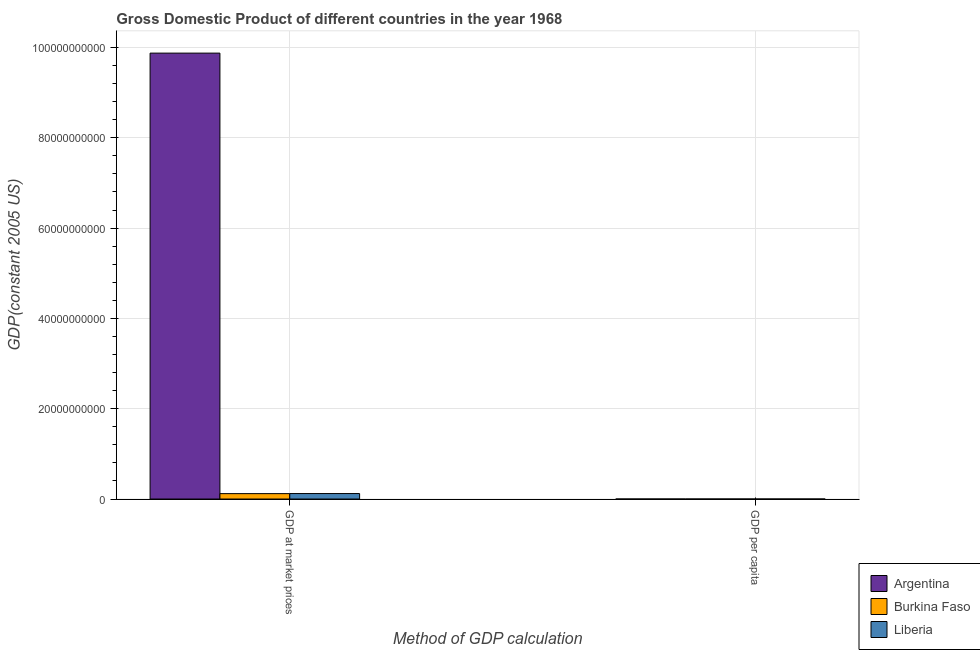Are the number of bars per tick equal to the number of legend labels?
Your answer should be very brief. Yes. Are the number of bars on each tick of the X-axis equal?
Ensure brevity in your answer.  Yes. How many bars are there on the 2nd tick from the left?
Offer a terse response. 3. What is the label of the 1st group of bars from the left?
Give a very brief answer. GDP at market prices. What is the gdp at market prices in Argentina?
Provide a succinct answer. 9.88e+1. Across all countries, what is the maximum gdp at market prices?
Provide a succinct answer. 9.88e+1. Across all countries, what is the minimum gdp at market prices?
Keep it short and to the point. 1.20e+09. In which country was the gdp per capita minimum?
Provide a short and direct response. Burkina Faso. What is the total gdp at market prices in the graph?
Give a very brief answer. 1.01e+11. What is the difference between the gdp at market prices in Liberia and that in Burkina Faso?
Give a very brief answer. 1.54e+07. What is the difference between the gdp at market prices in Argentina and the gdp per capita in Burkina Faso?
Give a very brief answer. 9.88e+1. What is the average gdp at market prices per country?
Ensure brevity in your answer.  3.37e+1. What is the difference between the gdp at market prices and gdp per capita in Liberia?
Your answer should be compact. 1.21e+09. What is the ratio of the gdp at market prices in Argentina to that in Liberia?
Make the answer very short. 81.49. In how many countries, is the gdp per capita greater than the average gdp per capita taken over all countries?
Your answer should be compact. 1. What does the 2nd bar from the left in GDP at market prices represents?
Offer a very short reply. Burkina Faso. What does the 3rd bar from the right in GDP at market prices represents?
Provide a succinct answer. Argentina. How many bars are there?
Ensure brevity in your answer.  6. Are all the bars in the graph horizontal?
Give a very brief answer. No. How many countries are there in the graph?
Offer a terse response. 3. What is the difference between two consecutive major ticks on the Y-axis?
Give a very brief answer. 2.00e+1. What is the title of the graph?
Your answer should be very brief. Gross Domestic Product of different countries in the year 1968. What is the label or title of the X-axis?
Your answer should be compact. Method of GDP calculation. What is the label or title of the Y-axis?
Provide a short and direct response. GDP(constant 2005 US). What is the GDP(constant 2005 US) in Argentina in GDP at market prices?
Give a very brief answer. 9.88e+1. What is the GDP(constant 2005 US) in Burkina Faso in GDP at market prices?
Keep it short and to the point. 1.20e+09. What is the GDP(constant 2005 US) of Liberia in GDP at market prices?
Offer a very short reply. 1.21e+09. What is the GDP(constant 2005 US) of Argentina in GDP per capita?
Provide a short and direct response. 4245.61. What is the GDP(constant 2005 US) in Burkina Faso in GDP per capita?
Offer a terse response. 220.19. What is the GDP(constant 2005 US) in Liberia in GDP per capita?
Ensure brevity in your answer.  898.75. Across all Method of GDP calculation, what is the maximum GDP(constant 2005 US) in Argentina?
Your answer should be very brief. 9.88e+1. Across all Method of GDP calculation, what is the maximum GDP(constant 2005 US) of Burkina Faso?
Offer a terse response. 1.20e+09. Across all Method of GDP calculation, what is the maximum GDP(constant 2005 US) of Liberia?
Offer a very short reply. 1.21e+09. Across all Method of GDP calculation, what is the minimum GDP(constant 2005 US) in Argentina?
Offer a very short reply. 4245.61. Across all Method of GDP calculation, what is the minimum GDP(constant 2005 US) in Burkina Faso?
Provide a short and direct response. 220.19. Across all Method of GDP calculation, what is the minimum GDP(constant 2005 US) of Liberia?
Offer a very short reply. 898.75. What is the total GDP(constant 2005 US) in Argentina in the graph?
Your answer should be compact. 9.88e+1. What is the total GDP(constant 2005 US) of Burkina Faso in the graph?
Offer a terse response. 1.20e+09. What is the total GDP(constant 2005 US) in Liberia in the graph?
Ensure brevity in your answer.  1.21e+09. What is the difference between the GDP(constant 2005 US) of Argentina in GDP at market prices and that in GDP per capita?
Make the answer very short. 9.88e+1. What is the difference between the GDP(constant 2005 US) of Burkina Faso in GDP at market prices and that in GDP per capita?
Provide a succinct answer. 1.20e+09. What is the difference between the GDP(constant 2005 US) of Liberia in GDP at market prices and that in GDP per capita?
Your response must be concise. 1.21e+09. What is the difference between the GDP(constant 2005 US) of Argentina in GDP at market prices and the GDP(constant 2005 US) of Burkina Faso in GDP per capita?
Offer a very short reply. 9.88e+1. What is the difference between the GDP(constant 2005 US) of Argentina in GDP at market prices and the GDP(constant 2005 US) of Liberia in GDP per capita?
Make the answer very short. 9.88e+1. What is the difference between the GDP(constant 2005 US) of Burkina Faso in GDP at market prices and the GDP(constant 2005 US) of Liberia in GDP per capita?
Provide a short and direct response. 1.20e+09. What is the average GDP(constant 2005 US) of Argentina per Method of GDP calculation?
Provide a short and direct response. 4.94e+1. What is the average GDP(constant 2005 US) in Burkina Faso per Method of GDP calculation?
Ensure brevity in your answer.  5.98e+08. What is the average GDP(constant 2005 US) of Liberia per Method of GDP calculation?
Your response must be concise. 6.06e+08. What is the difference between the GDP(constant 2005 US) of Argentina and GDP(constant 2005 US) of Burkina Faso in GDP at market prices?
Keep it short and to the point. 9.76e+1. What is the difference between the GDP(constant 2005 US) in Argentina and GDP(constant 2005 US) in Liberia in GDP at market prices?
Keep it short and to the point. 9.75e+1. What is the difference between the GDP(constant 2005 US) in Burkina Faso and GDP(constant 2005 US) in Liberia in GDP at market prices?
Your answer should be very brief. -1.54e+07. What is the difference between the GDP(constant 2005 US) of Argentina and GDP(constant 2005 US) of Burkina Faso in GDP per capita?
Offer a very short reply. 4025.43. What is the difference between the GDP(constant 2005 US) in Argentina and GDP(constant 2005 US) in Liberia in GDP per capita?
Your answer should be very brief. 3346.86. What is the difference between the GDP(constant 2005 US) in Burkina Faso and GDP(constant 2005 US) in Liberia in GDP per capita?
Make the answer very short. -678.56. What is the ratio of the GDP(constant 2005 US) of Argentina in GDP at market prices to that in GDP per capita?
Make the answer very short. 2.33e+07. What is the ratio of the GDP(constant 2005 US) of Burkina Faso in GDP at market prices to that in GDP per capita?
Ensure brevity in your answer.  5.43e+06. What is the ratio of the GDP(constant 2005 US) of Liberia in GDP at market prices to that in GDP per capita?
Make the answer very short. 1.35e+06. What is the difference between the highest and the second highest GDP(constant 2005 US) in Argentina?
Ensure brevity in your answer.  9.88e+1. What is the difference between the highest and the second highest GDP(constant 2005 US) in Burkina Faso?
Make the answer very short. 1.20e+09. What is the difference between the highest and the second highest GDP(constant 2005 US) of Liberia?
Your answer should be compact. 1.21e+09. What is the difference between the highest and the lowest GDP(constant 2005 US) in Argentina?
Provide a succinct answer. 9.88e+1. What is the difference between the highest and the lowest GDP(constant 2005 US) in Burkina Faso?
Provide a succinct answer. 1.20e+09. What is the difference between the highest and the lowest GDP(constant 2005 US) of Liberia?
Offer a very short reply. 1.21e+09. 